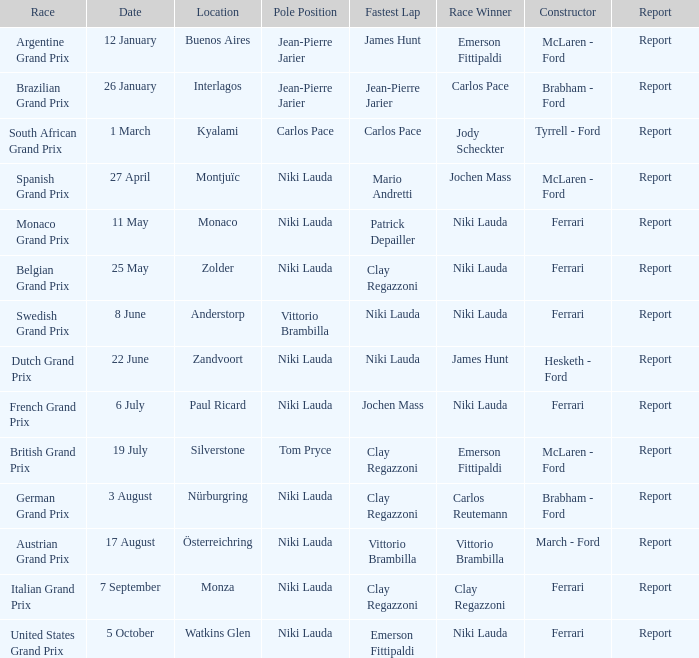In which location did the group featuring tom pryce in pole position race? Silverstone. 